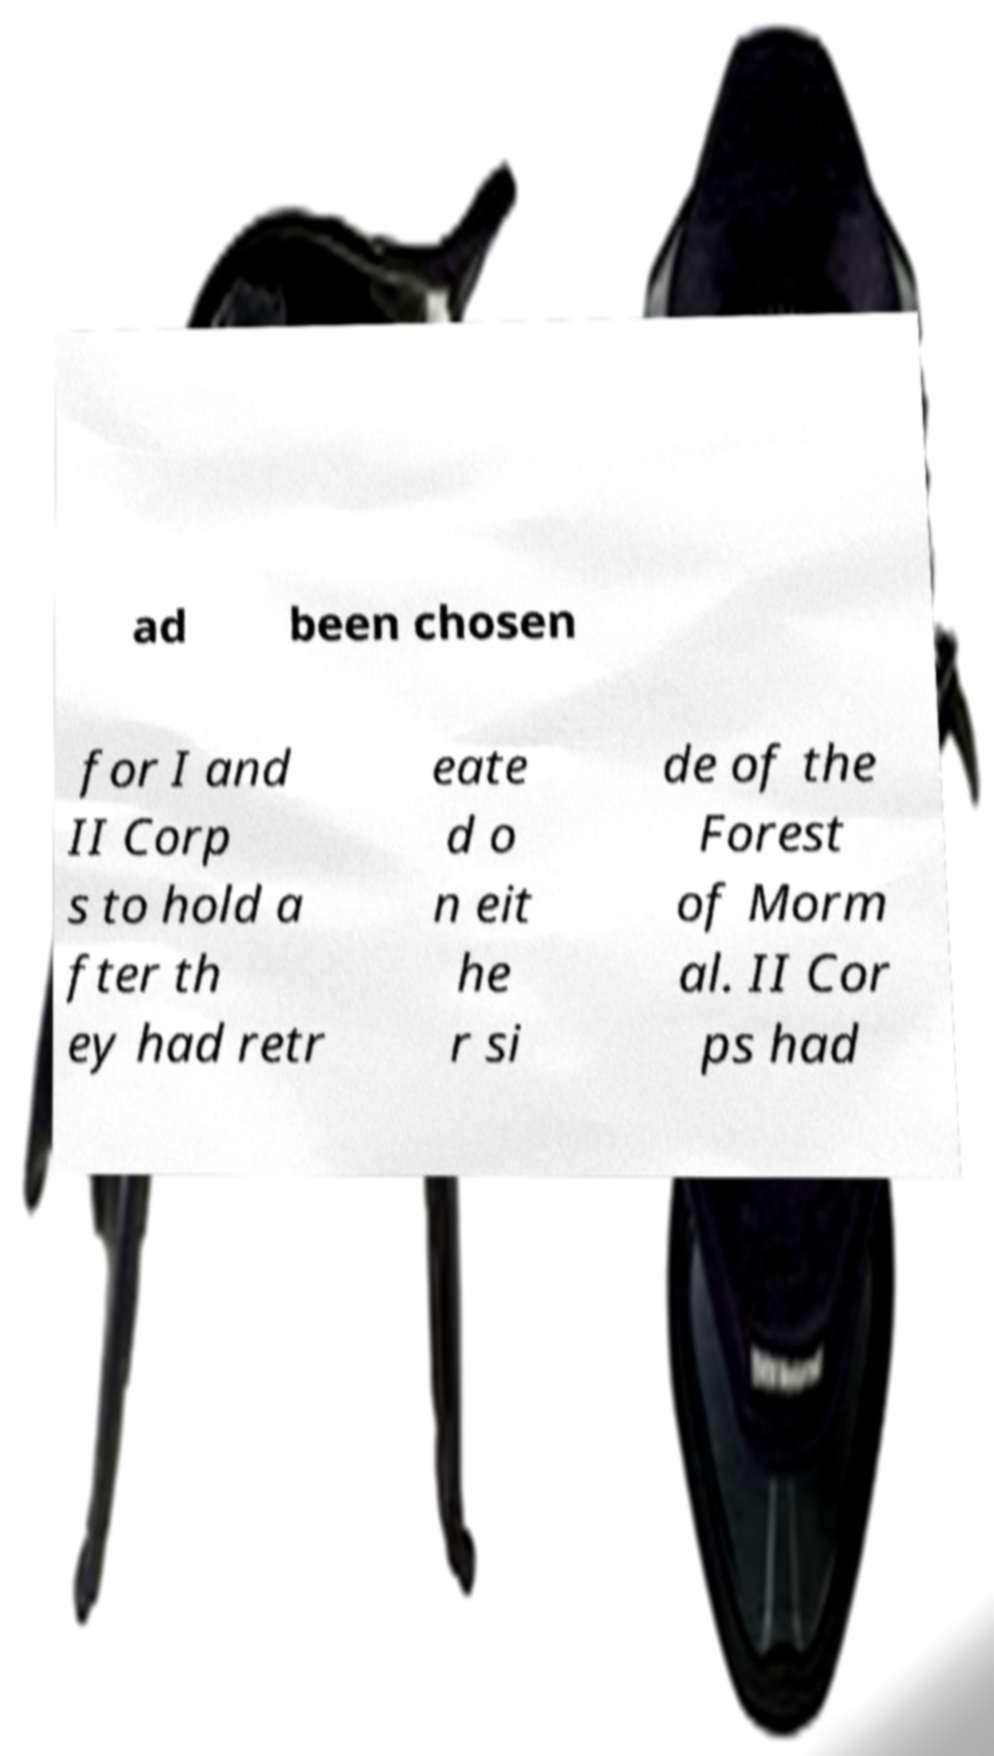There's text embedded in this image that I need extracted. Can you transcribe it verbatim? ad been chosen for I and II Corp s to hold a fter th ey had retr eate d o n eit he r si de of the Forest of Morm al. II Cor ps had 